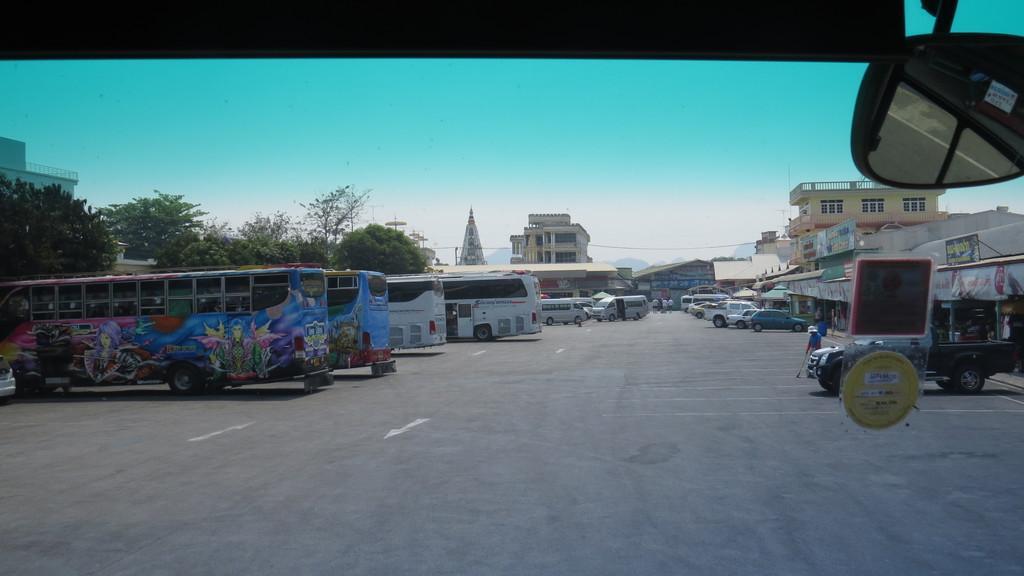Could you give a brief overview of what you see in this image? This image is clicked outside. There are buses in the middle. There are cars in the middle. There are buildings in the middle. There are trees on the left side. There is sky at the top. 